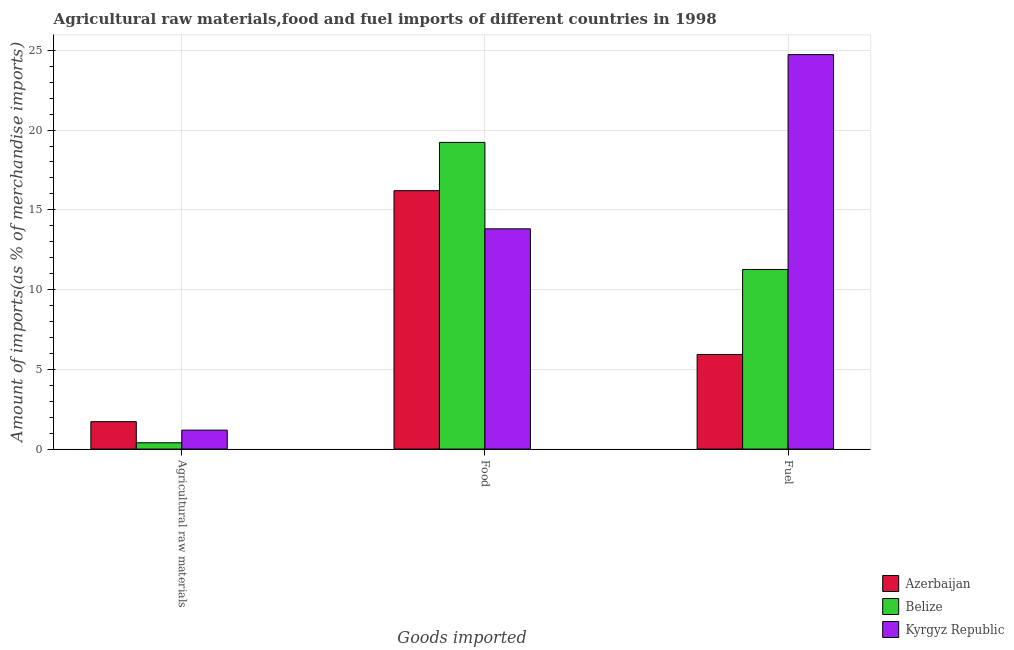How many different coloured bars are there?
Your response must be concise. 3. Are the number of bars on each tick of the X-axis equal?
Your response must be concise. Yes. How many bars are there on the 1st tick from the left?
Offer a very short reply. 3. How many bars are there on the 2nd tick from the right?
Provide a short and direct response. 3. What is the label of the 1st group of bars from the left?
Your answer should be compact. Agricultural raw materials. What is the percentage of food imports in Azerbaijan?
Offer a terse response. 16.2. Across all countries, what is the maximum percentage of food imports?
Provide a succinct answer. 19.23. Across all countries, what is the minimum percentage of raw materials imports?
Offer a very short reply. 0.4. In which country was the percentage of raw materials imports maximum?
Give a very brief answer. Azerbaijan. In which country was the percentage of fuel imports minimum?
Provide a short and direct response. Azerbaijan. What is the total percentage of fuel imports in the graph?
Ensure brevity in your answer.  41.92. What is the difference between the percentage of food imports in Belize and that in Kyrgyz Republic?
Offer a terse response. 5.42. What is the difference between the percentage of raw materials imports in Azerbaijan and the percentage of fuel imports in Kyrgyz Republic?
Your answer should be very brief. -23.01. What is the average percentage of raw materials imports per country?
Make the answer very short. 1.1. What is the difference between the percentage of food imports and percentage of raw materials imports in Azerbaijan?
Ensure brevity in your answer.  14.48. What is the ratio of the percentage of fuel imports in Belize to that in Azerbaijan?
Offer a very short reply. 1.9. Is the percentage of fuel imports in Azerbaijan less than that in Kyrgyz Republic?
Your response must be concise. Yes. What is the difference between the highest and the second highest percentage of fuel imports?
Your response must be concise. 13.47. What is the difference between the highest and the lowest percentage of food imports?
Your answer should be compact. 5.42. Is the sum of the percentage of raw materials imports in Kyrgyz Republic and Belize greater than the maximum percentage of food imports across all countries?
Give a very brief answer. No. What does the 1st bar from the left in Agricultural raw materials represents?
Your answer should be very brief. Azerbaijan. What does the 3rd bar from the right in Agricultural raw materials represents?
Your answer should be compact. Azerbaijan. Is it the case that in every country, the sum of the percentage of raw materials imports and percentage of food imports is greater than the percentage of fuel imports?
Offer a very short reply. No. How many bars are there?
Your answer should be very brief. 9. How many countries are there in the graph?
Offer a terse response. 3. Are the values on the major ticks of Y-axis written in scientific E-notation?
Your answer should be compact. No. Does the graph contain grids?
Offer a terse response. Yes. How many legend labels are there?
Keep it short and to the point. 3. What is the title of the graph?
Keep it short and to the point. Agricultural raw materials,food and fuel imports of different countries in 1998. Does "Switzerland" appear as one of the legend labels in the graph?
Your answer should be very brief. No. What is the label or title of the X-axis?
Give a very brief answer. Goods imported. What is the label or title of the Y-axis?
Make the answer very short. Amount of imports(as % of merchandise imports). What is the Amount of imports(as % of merchandise imports) in Azerbaijan in Agricultural raw materials?
Provide a short and direct response. 1.72. What is the Amount of imports(as % of merchandise imports) of Belize in Agricultural raw materials?
Provide a short and direct response. 0.4. What is the Amount of imports(as % of merchandise imports) of Kyrgyz Republic in Agricultural raw materials?
Your response must be concise. 1.19. What is the Amount of imports(as % of merchandise imports) in Azerbaijan in Food?
Your response must be concise. 16.2. What is the Amount of imports(as % of merchandise imports) in Belize in Food?
Provide a succinct answer. 19.23. What is the Amount of imports(as % of merchandise imports) of Kyrgyz Republic in Food?
Your response must be concise. 13.81. What is the Amount of imports(as % of merchandise imports) in Azerbaijan in Fuel?
Ensure brevity in your answer.  5.93. What is the Amount of imports(as % of merchandise imports) of Belize in Fuel?
Ensure brevity in your answer.  11.26. What is the Amount of imports(as % of merchandise imports) in Kyrgyz Republic in Fuel?
Your response must be concise. 24.73. Across all Goods imported, what is the maximum Amount of imports(as % of merchandise imports) in Azerbaijan?
Ensure brevity in your answer.  16.2. Across all Goods imported, what is the maximum Amount of imports(as % of merchandise imports) in Belize?
Your answer should be very brief. 19.23. Across all Goods imported, what is the maximum Amount of imports(as % of merchandise imports) of Kyrgyz Republic?
Keep it short and to the point. 24.73. Across all Goods imported, what is the minimum Amount of imports(as % of merchandise imports) in Azerbaijan?
Offer a terse response. 1.72. Across all Goods imported, what is the minimum Amount of imports(as % of merchandise imports) in Belize?
Give a very brief answer. 0.4. Across all Goods imported, what is the minimum Amount of imports(as % of merchandise imports) of Kyrgyz Republic?
Provide a short and direct response. 1.19. What is the total Amount of imports(as % of merchandise imports) of Azerbaijan in the graph?
Provide a short and direct response. 23.85. What is the total Amount of imports(as % of merchandise imports) in Belize in the graph?
Make the answer very short. 30.88. What is the total Amount of imports(as % of merchandise imports) of Kyrgyz Republic in the graph?
Provide a succinct answer. 39.73. What is the difference between the Amount of imports(as % of merchandise imports) in Azerbaijan in Agricultural raw materials and that in Food?
Keep it short and to the point. -14.48. What is the difference between the Amount of imports(as % of merchandise imports) in Belize in Agricultural raw materials and that in Food?
Your response must be concise. -18.83. What is the difference between the Amount of imports(as % of merchandise imports) in Kyrgyz Republic in Agricultural raw materials and that in Food?
Your response must be concise. -12.62. What is the difference between the Amount of imports(as % of merchandise imports) in Azerbaijan in Agricultural raw materials and that in Fuel?
Ensure brevity in your answer.  -4.21. What is the difference between the Amount of imports(as % of merchandise imports) in Belize in Agricultural raw materials and that in Fuel?
Give a very brief answer. -10.86. What is the difference between the Amount of imports(as % of merchandise imports) of Kyrgyz Republic in Agricultural raw materials and that in Fuel?
Offer a very short reply. -23.54. What is the difference between the Amount of imports(as % of merchandise imports) of Azerbaijan in Food and that in Fuel?
Keep it short and to the point. 10.27. What is the difference between the Amount of imports(as % of merchandise imports) of Belize in Food and that in Fuel?
Provide a short and direct response. 7.97. What is the difference between the Amount of imports(as % of merchandise imports) in Kyrgyz Republic in Food and that in Fuel?
Provide a short and direct response. -10.92. What is the difference between the Amount of imports(as % of merchandise imports) of Azerbaijan in Agricultural raw materials and the Amount of imports(as % of merchandise imports) of Belize in Food?
Provide a short and direct response. -17.51. What is the difference between the Amount of imports(as % of merchandise imports) in Azerbaijan in Agricultural raw materials and the Amount of imports(as % of merchandise imports) in Kyrgyz Republic in Food?
Offer a very short reply. -12.09. What is the difference between the Amount of imports(as % of merchandise imports) in Belize in Agricultural raw materials and the Amount of imports(as % of merchandise imports) in Kyrgyz Republic in Food?
Provide a succinct answer. -13.41. What is the difference between the Amount of imports(as % of merchandise imports) in Azerbaijan in Agricultural raw materials and the Amount of imports(as % of merchandise imports) in Belize in Fuel?
Keep it short and to the point. -9.54. What is the difference between the Amount of imports(as % of merchandise imports) of Azerbaijan in Agricultural raw materials and the Amount of imports(as % of merchandise imports) of Kyrgyz Republic in Fuel?
Ensure brevity in your answer.  -23.01. What is the difference between the Amount of imports(as % of merchandise imports) in Belize in Agricultural raw materials and the Amount of imports(as % of merchandise imports) in Kyrgyz Republic in Fuel?
Keep it short and to the point. -24.33. What is the difference between the Amount of imports(as % of merchandise imports) of Azerbaijan in Food and the Amount of imports(as % of merchandise imports) of Belize in Fuel?
Offer a very short reply. 4.94. What is the difference between the Amount of imports(as % of merchandise imports) of Azerbaijan in Food and the Amount of imports(as % of merchandise imports) of Kyrgyz Republic in Fuel?
Your answer should be very brief. -8.53. What is the difference between the Amount of imports(as % of merchandise imports) of Belize in Food and the Amount of imports(as % of merchandise imports) of Kyrgyz Republic in Fuel?
Ensure brevity in your answer.  -5.5. What is the average Amount of imports(as % of merchandise imports) of Azerbaijan per Goods imported?
Your response must be concise. 7.95. What is the average Amount of imports(as % of merchandise imports) of Belize per Goods imported?
Keep it short and to the point. 10.29. What is the average Amount of imports(as % of merchandise imports) in Kyrgyz Republic per Goods imported?
Give a very brief answer. 13.24. What is the difference between the Amount of imports(as % of merchandise imports) in Azerbaijan and Amount of imports(as % of merchandise imports) in Belize in Agricultural raw materials?
Make the answer very short. 1.32. What is the difference between the Amount of imports(as % of merchandise imports) in Azerbaijan and Amount of imports(as % of merchandise imports) in Kyrgyz Republic in Agricultural raw materials?
Keep it short and to the point. 0.53. What is the difference between the Amount of imports(as % of merchandise imports) in Belize and Amount of imports(as % of merchandise imports) in Kyrgyz Republic in Agricultural raw materials?
Offer a very short reply. -0.79. What is the difference between the Amount of imports(as % of merchandise imports) of Azerbaijan and Amount of imports(as % of merchandise imports) of Belize in Food?
Your answer should be very brief. -3.03. What is the difference between the Amount of imports(as % of merchandise imports) of Azerbaijan and Amount of imports(as % of merchandise imports) of Kyrgyz Republic in Food?
Make the answer very short. 2.39. What is the difference between the Amount of imports(as % of merchandise imports) of Belize and Amount of imports(as % of merchandise imports) of Kyrgyz Republic in Food?
Offer a terse response. 5.42. What is the difference between the Amount of imports(as % of merchandise imports) in Azerbaijan and Amount of imports(as % of merchandise imports) in Belize in Fuel?
Ensure brevity in your answer.  -5.33. What is the difference between the Amount of imports(as % of merchandise imports) in Azerbaijan and Amount of imports(as % of merchandise imports) in Kyrgyz Republic in Fuel?
Provide a short and direct response. -18.8. What is the difference between the Amount of imports(as % of merchandise imports) in Belize and Amount of imports(as % of merchandise imports) in Kyrgyz Republic in Fuel?
Offer a terse response. -13.47. What is the ratio of the Amount of imports(as % of merchandise imports) of Azerbaijan in Agricultural raw materials to that in Food?
Provide a short and direct response. 0.11. What is the ratio of the Amount of imports(as % of merchandise imports) in Belize in Agricultural raw materials to that in Food?
Provide a succinct answer. 0.02. What is the ratio of the Amount of imports(as % of merchandise imports) of Kyrgyz Republic in Agricultural raw materials to that in Food?
Keep it short and to the point. 0.09. What is the ratio of the Amount of imports(as % of merchandise imports) in Azerbaijan in Agricultural raw materials to that in Fuel?
Offer a very short reply. 0.29. What is the ratio of the Amount of imports(as % of merchandise imports) of Belize in Agricultural raw materials to that in Fuel?
Your response must be concise. 0.04. What is the ratio of the Amount of imports(as % of merchandise imports) in Kyrgyz Republic in Agricultural raw materials to that in Fuel?
Give a very brief answer. 0.05. What is the ratio of the Amount of imports(as % of merchandise imports) in Azerbaijan in Food to that in Fuel?
Make the answer very short. 2.73. What is the ratio of the Amount of imports(as % of merchandise imports) of Belize in Food to that in Fuel?
Provide a short and direct response. 1.71. What is the ratio of the Amount of imports(as % of merchandise imports) of Kyrgyz Republic in Food to that in Fuel?
Your answer should be compact. 0.56. What is the difference between the highest and the second highest Amount of imports(as % of merchandise imports) in Azerbaijan?
Provide a short and direct response. 10.27. What is the difference between the highest and the second highest Amount of imports(as % of merchandise imports) of Belize?
Offer a terse response. 7.97. What is the difference between the highest and the second highest Amount of imports(as % of merchandise imports) of Kyrgyz Republic?
Give a very brief answer. 10.92. What is the difference between the highest and the lowest Amount of imports(as % of merchandise imports) of Azerbaijan?
Your response must be concise. 14.48. What is the difference between the highest and the lowest Amount of imports(as % of merchandise imports) of Belize?
Keep it short and to the point. 18.83. What is the difference between the highest and the lowest Amount of imports(as % of merchandise imports) of Kyrgyz Republic?
Offer a very short reply. 23.54. 